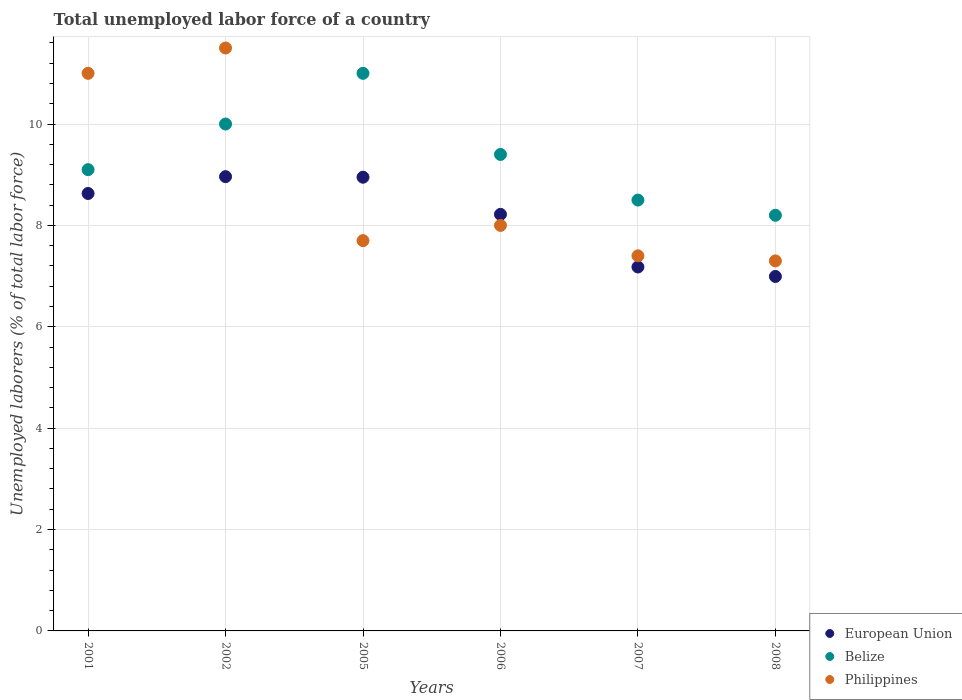How many different coloured dotlines are there?
Your answer should be compact. 3. Is the number of dotlines equal to the number of legend labels?
Your answer should be very brief. Yes. What is the total unemployed labor force in European Union in 2007?
Ensure brevity in your answer.  7.18. Across all years, what is the minimum total unemployed labor force in Philippines?
Your answer should be very brief. 7.3. In which year was the total unemployed labor force in European Union minimum?
Your answer should be very brief. 2008. What is the total total unemployed labor force in European Union in the graph?
Offer a terse response. 48.93. What is the difference between the total unemployed labor force in Belize in 2002 and that in 2008?
Ensure brevity in your answer.  1.8. What is the difference between the total unemployed labor force in European Union in 2001 and the total unemployed labor force in Belize in 2007?
Provide a succinct answer. 0.13. What is the average total unemployed labor force in Belize per year?
Offer a very short reply. 9.37. In the year 2005, what is the difference between the total unemployed labor force in Philippines and total unemployed labor force in European Union?
Make the answer very short. -1.25. In how many years, is the total unemployed labor force in Philippines greater than 2.8 %?
Give a very brief answer. 6. What is the ratio of the total unemployed labor force in Belize in 2005 to that in 2007?
Your response must be concise. 1.29. Is the total unemployed labor force in Belize in 2001 less than that in 2005?
Offer a very short reply. Yes. Is the difference between the total unemployed labor force in Philippines in 2006 and 2007 greater than the difference between the total unemployed labor force in European Union in 2006 and 2007?
Keep it short and to the point. No. What is the difference between the highest and the second highest total unemployed labor force in Belize?
Make the answer very short. 1. What is the difference between the highest and the lowest total unemployed labor force in European Union?
Ensure brevity in your answer.  1.97. In how many years, is the total unemployed labor force in Philippines greater than the average total unemployed labor force in Philippines taken over all years?
Offer a very short reply. 2. Is the sum of the total unemployed labor force in Belize in 2001 and 2008 greater than the maximum total unemployed labor force in Philippines across all years?
Your response must be concise. Yes. Is it the case that in every year, the sum of the total unemployed labor force in Philippines and total unemployed labor force in Belize  is greater than the total unemployed labor force in European Union?
Your answer should be very brief. Yes. Does the total unemployed labor force in Belize monotonically increase over the years?
Keep it short and to the point. No. Is the total unemployed labor force in European Union strictly greater than the total unemployed labor force in Belize over the years?
Your answer should be compact. No. How many years are there in the graph?
Provide a short and direct response. 6. What is the difference between two consecutive major ticks on the Y-axis?
Ensure brevity in your answer.  2. Does the graph contain any zero values?
Provide a succinct answer. No. Where does the legend appear in the graph?
Provide a short and direct response. Bottom right. How are the legend labels stacked?
Your response must be concise. Vertical. What is the title of the graph?
Keep it short and to the point. Total unemployed labor force of a country. What is the label or title of the Y-axis?
Ensure brevity in your answer.  Unemployed laborers (% of total labor force). What is the Unemployed laborers (% of total labor force) of European Union in 2001?
Give a very brief answer. 8.63. What is the Unemployed laborers (% of total labor force) of Belize in 2001?
Give a very brief answer. 9.1. What is the Unemployed laborers (% of total labor force) in European Union in 2002?
Ensure brevity in your answer.  8.96. What is the Unemployed laborers (% of total labor force) in Belize in 2002?
Provide a succinct answer. 10. What is the Unemployed laborers (% of total labor force) in Philippines in 2002?
Ensure brevity in your answer.  11.5. What is the Unemployed laborers (% of total labor force) in European Union in 2005?
Offer a terse response. 8.95. What is the Unemployed laborers (% of total labor force) of Philippines in 2005?
Your answer should be very brief. 7.7. What is the Unemployed laborers (% of total labor force) in European Union in 2006?
Your answer should be compact. 8.22. What is the Unemployed laborers (% of total labor force) of Belize in 2006?
Give a very brief answer. 9.4. What is the Unemployed laborers (% of total labor force) of European Union in 2007?
Your response must be concise. 7.18. What is the Unemployed laborers (% of total labor force) in Belize in 2007?
Give a very brief answer. 8.5. What is the Unemployed laborers (% of total labor force) of Philippines in 2007?
Provide a succinct answer. 7.4. What is the Unemployed laborers (% of total labor force) in European Union in 2008?
Your response must be concise. 6.99. What is the Unemployed laborers (% of total labor force) in Belize in 2008?
Your answer should be very brief. 8.2. What is the Unemployed laborers (% of total labor force) of Philippines in 2008?
Your answer should be very brief. 7.3. Across all years, what is the maximum Unemployed laborers (% of total labor force) in European Union?
Your answer should be compact. 8.96. Across all years, what is the maximum Unemployed laborers (% of total labor force) of Belize?
Your answer should be very brief. 11. Across all years, what is the minimum Unemployed laborers (% of total labor force) of European Union?
Your response must be concise. 6.99. Across all years, what is the minimum Unemployed laborers (% of total labor force) of Belize?
Your answer should be very brief. 8.2. Across all years, what is the minimum Unemployed laborers (% of total labor force) of Philippines?
Provide a succinct answer. 7.3. What is the total Unemployed laborers (% of total labor force) of European Union in the graph?
Provide a short and direct response. 48.93. What is the total Unemployed laborers (% of total labor force) of Belize in the graph?
Your answer should be very brief. 56.2. What is the total Unemployed laborers (% of total labor force) in Philippines in the graph?
Offer a terse response. 52.9. What is the difference between the Unemployed laborers (% of total labor force) of European Union in 2001 and that in 2002?
Your answer should be very brief. -0.33. What is the difference between the Unemployed laborers (% of total labor force) of European Union in 2001 and that in 2005?
Your answer should be very brief. -0.32. What is the difference between the Unemployed laborers (% of total labor force) in European Union in 2001 and that in 2006?
Offer a very short reply. 0.41. What is the difference between the Unemployed laborers (% of total labor force) in Philippines in 2001 and that in 2006?
Make the answer very short. 3. What is the difference between the Unemployed laborers (% of total labor force) in European Union in 2001 and that in 2007?
Your answer should be compact. 1.45. What is the difference between the Unemployed laborers (% of total labor force) of Belize in 2001 and that in 2007?
Your answer should be compact. 0.6. What is the difference between the Unemployed laborers (% of total labor force) of European Union in 2001 and that in 2008?
Your answer should be compact. 1.64. What is the difference between the Unemployed laborers (% of total labor force) in Philippines in 2001 and that in 2008?
Your response must be concise. 3.7. What is the difference between the Unemployed laborers (% of total labor force) in European Union in 2002 and that in 2005?
Keep it short and to the point. 0.01. What is the difference between the Unemployed laborers (% of total labor force) of Belize in 2002 and that in 2005?
Your answer should be compact. -1. What is the difference between the Unemployed laborers (% of total labor force) in European Union in 2002 and that in 2006?
Offer a very short reply. 0.74. What is the difference between the Unemployed laborers (% of total labor force) in European Union in 2002 and that in 2007?
Your response must be concise. 1.78. What is the difference between the Unemployed laborers (% of total labor force) in Belize in 2002 and that in 2007?
Provide a succinct answer. 1.5. What is the difference between the Unemployed laborers (% of total labor force) in European Union in 2002 and that in 2008?
Make the answer very short. 1.97. What is the difference between the Unemployed laborers (% of total labor force) of European Union in 2005 and that in 2006?
Give a very brief answer. 0.73. What is the difference between the Unemployed laborers (% of total labor force) of Belize in 2005 and that in 2006?
Give a very brief answer. 1.6. What is the difference between the Unemployed laborers (% of total labor force) of Philippines in 2005 and that in 2006?
Give a very brief answer. -0.3. What is the difference between the Unemployed laborers (% of total labor force) of European Union in 2005 and that in 2007?
Make the answer very short. 1.77. What is the difference between the Unemployed laborers (% of total labor force) of Belize in 2005 and that in 2007?
Provide a short and direct response. 2.5. What is the difference between the Unemployed laborers (% of total labor force) in Philippines in 2005 and that in 2007?
Provide a succinct answer. 0.3. What is the difference between the Unemployed laborers (% of total labor force) of European Union in 2005 and that in 2008?
Your response must be concise. 1.96. What is the difference between the Unemployed laborers (% of total labor force) in Belize in 2005 and that in 2008?
Provide a succinct answer. 2.8. What is the difference between the Unemployed laborers (% of total labor force) in European Union in 2006 and that in 2007?
Provide a succinct answer. 1.04. What is the difference between the Unemployed laborers (% of total labor force) of European Union in 2006 and that in 2008?
Ensure brevity in your answer.  1.23. What is the difference between the Unemployed laborers (% of total labor force) in Belize in 2006 and that in 2008?
Your answer should be very brief. 1.2. What is the difference between the Unemployed laborers (% of total labor force) of European Union in 2007 and that in 2008?
Give a very brief answer. 0.19. What is the difference between the Unemployed laborers (% of total labor force) in Belize in 2007 and that in 2008?
Ensure brevity in your answer.  0.3. What is the difference between the Unemployed laborers (% of total labor force) of Philippines in 2007 and that in 2008?
Provide a succinct answer. 0.1. What is the difference between the Unemployed laborers (% of total labor force) in European Union in 2001 and the Unemployed laborers (% of total labor force) in Belize in 2002?
Your answer should be very brief. -1.37. What is the difference between the Unemployed laborers (% of total labor force) in European Union in 2001 and the Unemployed laborers (% of total labor force) in Philippines in 2002?
Your answer should be compact. -2.87. What is the difference between the Unemployed laborers (% of total labor force) in European Union in 2001 and the Unemployed laborers (% of total labor force) in Belize in 2005?
Your answer should be compact. -2.37. What is the difference between the Unemployed laborers (% of total labor force) in European Union in 2001 and the Unemployed laborers (% of total labor force) in Philippines in 2005?
Your response must be concise. 0.93. What is the difference between the Unemployed laborers (% of total labor force) of Belize in 2001 and the Unemployed laborers (% of total labor force) of Philippines in 2005?
Keep it short and to the point. 1.4. What is the difference between the Unemployed laborers (% of total labor force) in European Union in 2001 and the Unemployed laborers (% of total labor force) in Belize in 2006?
Ensure brevity in your answer.  -0.77. What is the difference between the Unemployed laborers (% of total labor force) of European Union in 2001 and the Unemployed laborers (% of total labor force) of Philippines in 2006?
Make the answer very short. 0.63. What is the difference between the Unemployed laborers (% of total labor force) in Belize in 2001 and the Unemployed laborers (% of total labor force) in Philippines in 2006?
Provide a succinct answer. 1.1. What is the difference between the Unemployed laborers (% of total labor force) in European Union in 2001 and the Unemployed laborers (% of total labor force) in Belize in 2007?
Keep it short and to the point. 0.13. What is the difference between the Unemployed laborers (% of total labor force) of European Union in 2001 and the Unemployed laborers (% of total labor force) of Philippines in 2007?
Offer a terse response. 1.23. What is the difference between the Unemployed laborers (% of total labor force) of European Union in 2001 and the Unemployed laborers (% of total labor force) of Belize in 2008?
Make the answer very short. 0.43. What is the difference between the Unemployed laborers (% of total labor force) of European Union in 2001 and the Unemployed laborers (% of total labor force) of Philippines in 2008?
Give a very brief answer. 1.33. What is the difference between the Unemployed laborers (% of total labor force) in Belize in 2001 and the Unemployed laborers (% of total labor force) in Philippines in 2008?
Your answer should be compact. 1.8. What is the difference between the Unemployed laborers (% of total labor force) of European Union in 2002 and the Unemployed laborers (% of total labor force) of Belize in 2005?
Give a very brief answer. -2.04. What is the difference between the Unemployed laborers (% of total labor force) in European Union in 2002 and the Unemployed laborers (% of total labor force) in Philippines in 2005?
Make the answer very short. 1.26. What is the difference between the Unemployed laborers (% of total labor force) in Belize in 2002 and the Unemployed laborers (% of total labor force) in Philippines in 2005?
Offer a very short reply. 2.3. What is the difference between the Unemployed laborers (% of total labor force) of European Union in 2002 and the Unemployed laborers (% of total labor force) of Belize in 2006?
Provide a short and direct response. -0.44. What is the difference between the Unemployed laborers (% of total labor force) in European Union in 2002 and the Unemployed laborers (% of total labor force) in Philippines in 2006?
Your answer should be very brief. 0.96. What is the difference between the Unemployed laborers (% of total labor force) of Belize in 2002 and the Unemployed laborers (% of total labor force) of Philippines in 2006?
Keep it short and to the point. 2. What is the difference between the Unemployed laborers (% of total labor force) of European Union in 2002 and the Unemployed laborers (% of total labor force) of Belize in 2007?
Offer a very short reply. 0.46. What is the difference between the Unemployed laborers (% of total labor force) of European Union in 2002 and the Unemployed laborers (% of total labor force) of Philippines in 2007?
Provide a short and direct response. 1.56. What is the difference between the Unemployed laborers (% of total labor force) of European Union in 2002 and the Unemployed laborers (% of total labor force) of Belize in 2008?
Offer a terse response. 0.76. What is the difference between the Unemployed laborers (% of total labor force) of European Union in 2002 and the Unemployed laborers (% of total labor force) of Philippines in 2008?
Keep it short and to the point. 1.66. What is the difference between the Unemployed laborers (% of total labor force) in European Union in 2005 and the Unemployed laborers (% of total labor force) in Belize in 2006?
Provide a succinct answer. -0.45. What is the difference between the Unemployed laborers (% of total labor force) of European Union in 2005 and the Unemployed laborers (% of total labor force) of Philippines in 2006?
Give a very brief answer. 0.95. What is the difference between the Unemployed laborers (% of total labor force) of European Union in 2005 and the Unemployed laborers (% of total labor force) of Belize in 2007?
Your answer should be very brief. 0.45. What is the difference between the Unemployed laborers (% of total labor force) in European Union in 2005 and the Unemployed laborers (% of total labor force) in Philippines in 2007?
Offer a very short reply. 1.55. What is the difference between the Unemployed laborers (% of total labor force) in European Union in 2005 and the Unemployed laborers (% of total labor force) in Belize in 2008?
Ensure brevity in your answer.  0.75. What is the difference between the Unemployed laborers (% of total labor force) in European Union in 2005 and the Unemployed laborers (% of total labor force) in Philippines in 2008?
Your answer should be very brief. 1.65. What is the difference between the Unemployed laborers (% of total labor force) in European Union in 2006 and the Unemployed laborers (% of total labor force) in Belize in 2007?
Give a very brief answer. -0.28. What is the difference between the Unemployed laborers (% of total labor force) in European Union in 2006 and the Unemployed laborers (% of total labor force) in Philippines in 2007?
Provide a succinct answer. 0.82. What is the difference between the Unemployed laborers (% of total labor force) in Belize in 2006 and the Unemployed laborers (% of total labor force) in Philippines in 2007?
Provide a succinct answer. 2. What is the difference between the Unemployed laborers (% of total labor force) in European Union in 2006 and the Unemployed laborers (% of total labor force) in Belize in 2008?
Your answer should be compact. 0.02. What is the difference between the Unemployed laborers (% of total labor force) in European Union in 2006 and the Unemployed laborers (% of total labor force) in Philippines in 2008?
Give a very brief answer. 0.92. What is the difference between the Unemployed laborers (% of total labor force) of European Union in 2007 and the Unemployed laborers (% of total labor force) of Belize in 2008?
Your answer should be compact. -1.02. What is the difference between the Unemployed laborers (% of total labor force) of European Union in 2007 and the Unemployed laborers (% of total labor force) of Philippines in 2008?
Offer a very short reply. -0.12. What is the average Unemployed laborers (% of total labor force) of European Union per year?
Provide a short and direct response. 8.16. What is the average Unemployed laborers (% of total labor force) in Belize per year?
Make the answer very short. 9.37. What is the average Unemployed laborers (% of total labor force) in Philippines per year?
Your response must be concise. 8.82. In the year 2001, what is the difference between the Unemployed laborers (% of total labor force) of European Union and Unemployed laborers (% of total labor force) of Belize?
Make the answer very short. -0.47. In the year 2001, what is the difference between the Unemployed laborers (% of total labor force) in European Union and Unemployed laborers (% of total labor force) in Philippines?
Provide a succinct answer. -2.37. In the year 2001, what is the difference between the Unemployed laborers (% of total labor force) in Belize and Unemployed laborers (% of total labor force) in Philippines?
Your response must be concise. -1.9. In the year 2002, what is the difference between the Unemployed laborers (% of total labor force) of European Union and Unemployed laborers (% of total labor force) of Belize?
Provide a succinct answer. -1.04. In the year 2002, what is the difference between the Unemployed laborers (% of total labor force) in European Union and Unemployed laborers (% of total labor force) in Philippines?
Keep it short and to the point. -2.54. In the year 2002, what is the difference between the Unemployed laborers (% of total labor force) of Belize and Unemployed laborers (% of total labor force) of Philippines?
Your response must be concise. -1.5. In the year 2005, what is the difference between the Unemployed laborers (% of total labor force) of European Union and Unemployed laborers (% of total labor force) of Belize?
Ensure brevity in your answer.  -2.05. In the year 2005, what is the difference between the Unemployed laborers (% of total labor force) of European Union and Unemployed laborers (% of total labor force) of Philippines?
Make the answer very short. 1.25. In the year 2005, what is the difference between the Unemployed laborers (% of total labor force) of Belize and Unemployed laborers (% of total labor force) of Philippines?
Keep it short and to the point. 3.3. In the year 2006, what is the difference between the Unemployed laborers (% of total labor force) in European Union and Unemployed laborers (% of total labor force) in Belize?
Provide a succinct answer. -1.18. In the year 2006, what is the difference between the Unemployed laborers (% of total labor force) in European Union and Unemployed laborers (% of total labor force) in Philippines?
Provide a short and direct response. 0.22. In the year 2006, what is the difference between the Unemployed laborers (% of total labor force) of Belize and Unemployed laborers (% of total labor force) of Philippines?
Keep it short and to the point. 1.4. In the year 2007, what is the difference between the Unemployed laborers (% of total labor force) in European Union and Unemployed laborers (% of total labor force) in Belize?
Your answer should be very brief. -1.32. In the year 2007, what is the difference between the Unemployed laborers (% of total labor force) in European Union and Unemployed laborers (% of total labor force) in Philippines?
Offer a very short reply. -0.22. In the year 2008, what is the difference between the Unemployed laborers (% of total labor force) in European Union and Unemployed laborers (% of total labor force) in Belize?
Your answer should be very brief. -1.21. In the year 2008, what is the difference between the Unemployed laborers (% of total labor force) of European Union and Unemployed laborers (% of total labor force) of Philippines?
Ensure brevity in your answer.  -0.31. In the year 2008, what is the difference between the Unemployed laborers (% of total labor force) of Belize and Unemployed laborers (% of total labor force) of Philippines?
Your response must be concise. 0.9. What is the ratio of the Unemployed laborers (% of total labor force) in European Union in 2001 to that in 2002?
Your answer should be very brief. 0.96. What is the ratio of the Unemployed laborers (% of total labor force) of Belize in 2001 to that in 2002?
Provide a succinct answer. 0.91. What is the ratio of the Unemployed laborers (% of total labor force) in Philippines in 2001 to that in 2002?
Offer a very short reply. 0.96. What is the ratio of the Unemployed laborers (% of total labor force) in European Union in 2001 to that in 2005?
Offer a terse response. 0.96. What is the ratio of the Unemployed laborers (% of total labor force) of Belize in 2001 to that in 2005?
Your response must be concise. 0.83. What is the ratio of the Unemployed laborers (% of total labor force) of Philippines in 2001 to that in 2005?
Offer a terse response. 1.43. What is the ratio of the Unemployed laborers (% of total labor force) in European Union in 2001 to that in 2006?
Provide a succinct answer. 1.05. What is the ratio of the Unemployed laborers (% of total labor force) of Belize in 2001 to that in 2006?
Offer a very short reply. 0.97. What is the ratio of the Unemployed laborers (% of total labor force) of Philippines in 2001 to that in 2006?
Provide a short and direct response. 1.38. What is the ratio of the Unemployed laborers (% of total labor force) in European Union in 2001 to that in 2007?
Your response must be concise. 1.2. What is the ratio of the Unemployed laborers (% of total labor force) in Belize in 2001 to that in 2007?
Your response must be concise. 1.07. What is the ratio of the Unemployed laborers (% of total labor force) in Philippines in 2001 to that in 2007?
Your response must be concise. 1.49. What is the ratio of the Unemployed laborers (% of total labor force) in European Union in 2001 to that in 2008?
Give a very brief answer. 1.23. What is the ratio of the Unemployed laborers (% of total labor force) of Belize in 2001 to that in 2008?
Your answer should be compact. 1.11. What is the ratio of the Unemployed laborers (% of total labor force) in Philippines in 2001 to that in 2008?
Keep it short and to the point. 1.51. What is the ratio of the Unemployed laborers (% of total labor force) of Philippines in 2002 to that in 2005?
Give a very brief answer. 1.49. What is the ratio of the Unemployed laborers (% of total labor force) of European Union in 2002 to that in 2006?
Give a very brief answer. 1.09. What is the ratio of the Unemployed laborers (% of total labor force) of Belize in 2002 to that in 2006?
Give a very brief answer. 1.06. What is the ratio of the Unemployed laborers (% of total labor force) in Philippines in 2002 to that in 2006?
Make the answer very short. 1.44. What is the ratio of the Unemployed laborers (% of total labor force) in European Union in 2002 to that in 2007?
Your answer should be compact. 1.25. What is the ratio of the Unemployed laborers (% of total labor force) of Belize in 2002 to that in 2007?
Ensure brevity in your answer.  1.18. What is the ratio of the Unemployed laborers (% of total labor force) of Philippines in 2002 to that in 2007?
Ensure brevity in your answer.  1.55. What is the ratio of the Unemployed laborers (% of total labor force) in European Union in 2002 to that in 2008?
Your response must be concise. 1.28. What is the ratio of the Unemployed laborers (% of total labor force) of Belize in 2002 to that in 2008?
Offer a terse response. 1.22. What is the ratio of the Unemployed laborers (% of total labor force) of Philippines in 2002 to that in 2008?
Provide a succinct answer. 1.58. What is the ratio of the Unemployed laborers (% of total labor force) in European Union in 2005 to that in 2006?
Keep it short and to the point. 1.09. What is the ratio of the Unemployed laborers (% of total labor force) in Belize in 2005 to that in 2006?
Make the answer very short. 1.17. What is the ratio of the Unemployed laborers (% of total labor force) of Philippines in 2005 to that in 2006?
Provide a short and direct response. 0.96. What is the ratio of the Unemployed laborers (% of total labor force) in European Union in 2005 to that in 2007?
Make the answer very short. 1.25. What is the ratio of the Unemployed laborers (% of total labor force) in Belize in 2005 to that in 2007?
Ensure brevity in your answer.  1.29. What is the ratio of the Unemployed laborers (% of total labor force) in Philippines in 2005 to that in 2007?
Make the answer very short. 1.04. What is the ratio of the Unemployed laborers (% of total labor force) in European Union in 2005 to that in 2008?
Your answer should be compact. 1.28. What is the ratio of the Unemployed laborers (% of total labor force) of Belize in 2005 to that in 2008?
Your response must be concise. 1.34. What is the ratio of the Unemployed laborers (% of total labor force) of Philippines in 2005 to that in 2008?
Give a very brief answer. 1.05. What is the ratio of the Unemployed laborers (% of total labor force) of European Union in 2006 to that in 2007?
Offer a terse response. 1.14. What is the ratio of the Unemployed laborers (% of total labor force) of Belize in 2006 to that in 2007?
Make the answer very short. 1.11. What is the ratio of the Unemployed laborers (% of total labor force) of Philippines in 2006 to that in 2007?
Ensure brevity in your answer.  1.08. What is the ratio of the Unemployed laborers (% of total labor force) in European Union in 2006 to that in 2008?
Offer a very short reply. 1.18. What is the ratio of the Unemployed laborers (% of total labor force) of Belize in 2006 to that in 2008?
Keep it short and to the point. 1.15. What is the ratio of the Unemployed laborers (% of total labor force) of Philippines in 2006 to that in 2008?
Keep it short and to the point. 1.1. What is the ratio of the Unemployed laborers (% of total labor force) of European Union in 2007 to that in 2008?
Provide a short and direct response. 1.03. What is the ratio of the Unemployed laborers (% of total labor force) in Belize in 2007 to that in 2008?
Provide a short and direct response. 1.04. What is the ratio of the Unemployed laborers (% of total labor force) of Philippines in 2007 to that in 2008?
Provide a succinct answer. 1.01. What is the difference between the highest and the second highest Unemployed laborers (% of total labor force) in European Union?
Your answer should be very brief. 0.01. What is the difference between the highest and the lowest Unemployed laborers (% of total labor force) of European Union?
Keep it short and to the point. 1.97. What is the difference between the highest and the lowest Unemployed laborers (% of total labor force) of Belize?
Keep it short and to the point. 2.8. 